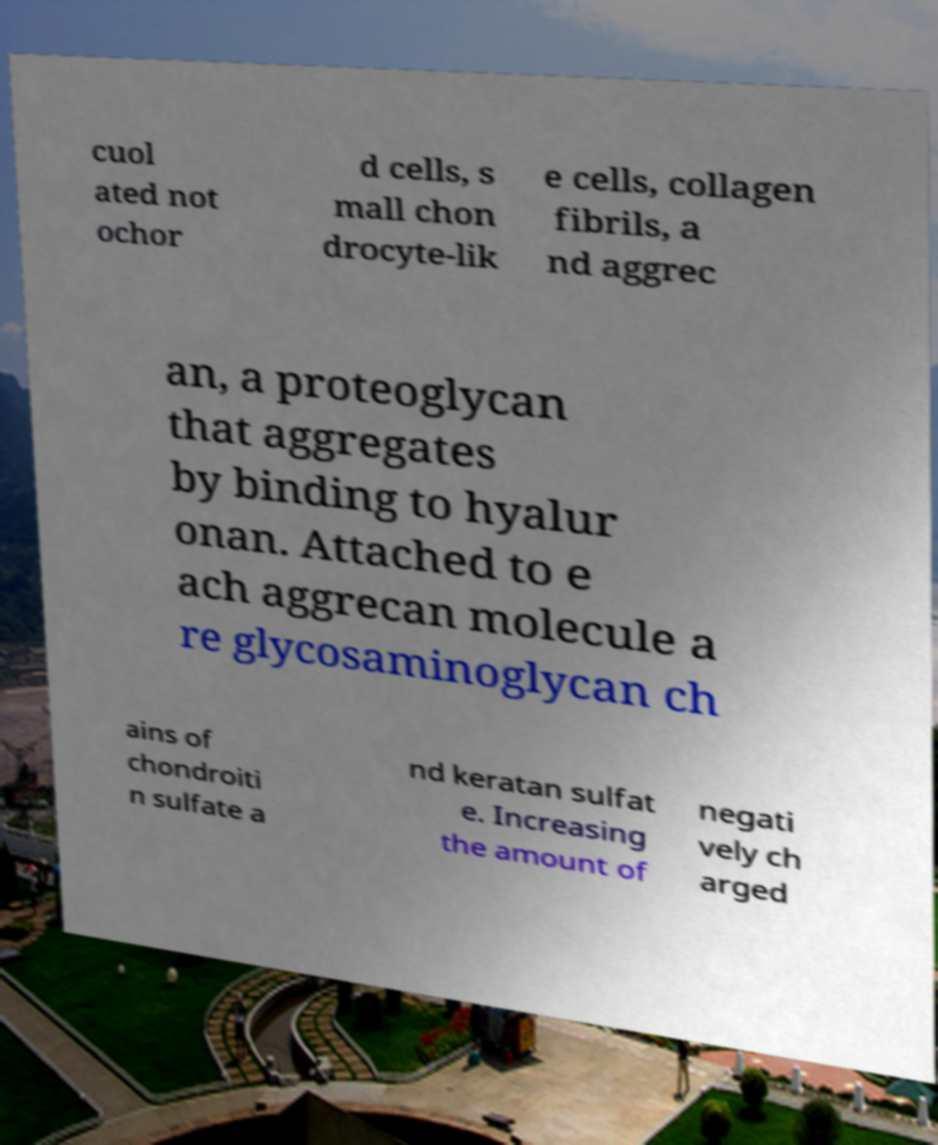For documentation purposes, I need the text within this image transcribed. Could you provide that? cuol ated not ochor d cells, s mall chon drocyte-lik e cells, collagen fibrils, a nd aggrec an, a proteoglycan that aggregates by binding to hyalur onan. Attached to e ach aggrecan molecule a re glycosaminoglycan ch ains of chondroiti n sulfate a nd keratan sulfat e. Increasing the amount of negati vely ch arged 